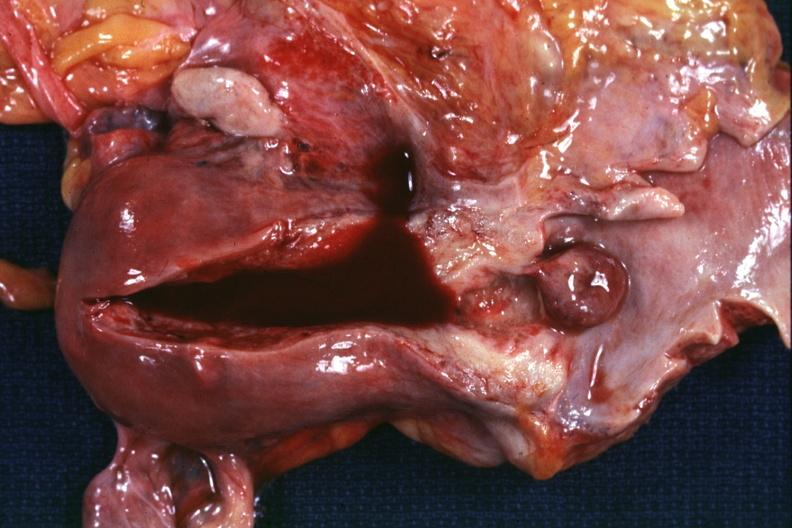where does this part belong to?
Answer the question using a single word or phrase. Female reproductive system 